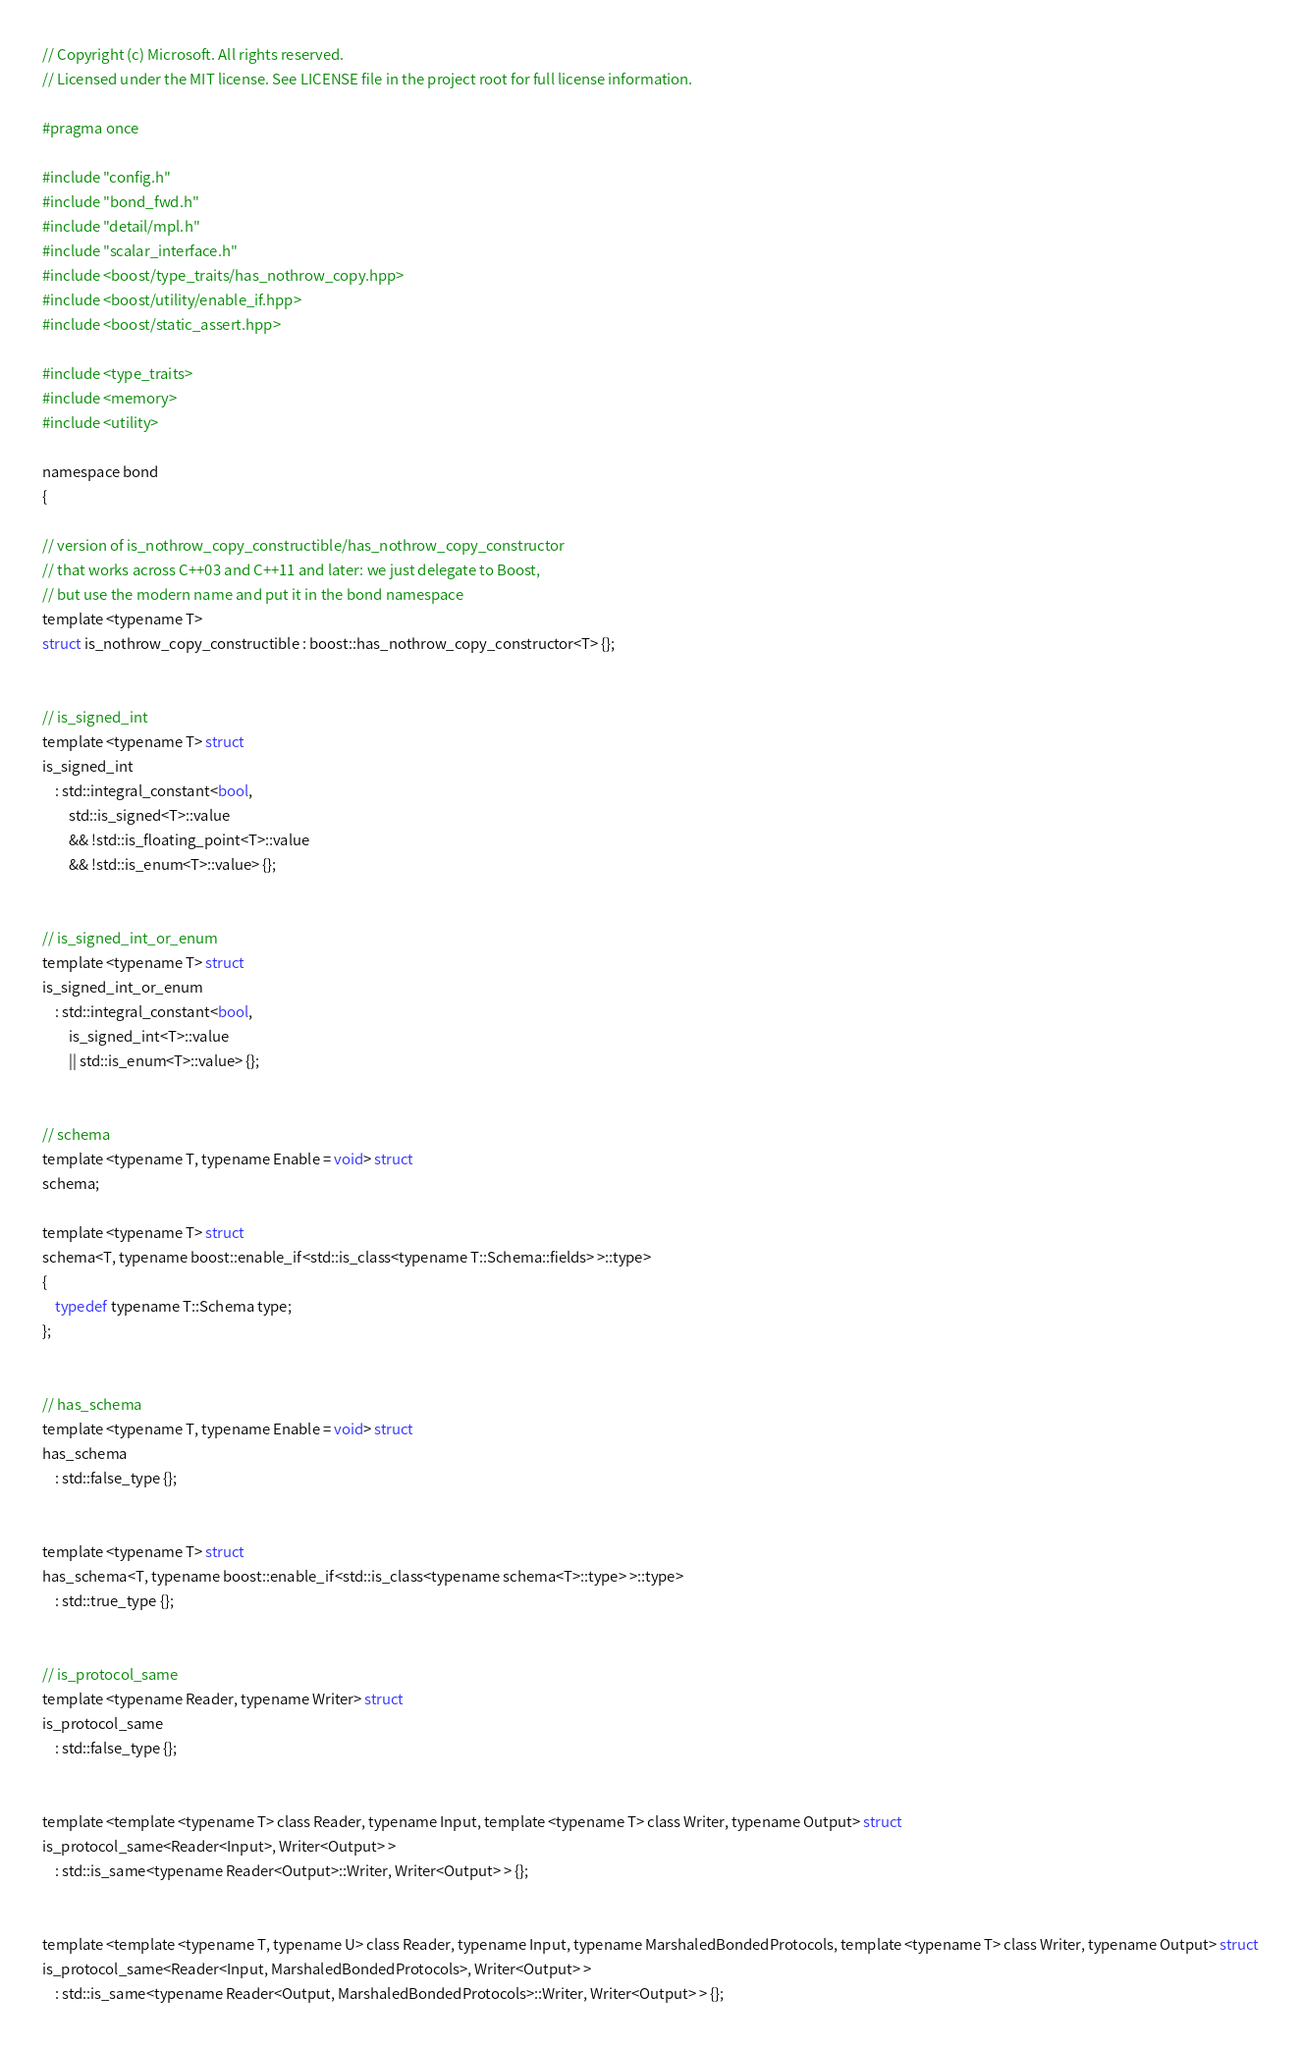Convert code to text. <code><loc_0><loc_0><loc_500><loc_500><_C_>// Copyright (c) Microsoft. All rights reserved.
// Licensed under the MIT license. See LICENSE file in the project root for full license information.

#pragma once

#include "config.h"
#include "bond_fwd.h"
#include "detail/mpl.h"
#include "scalar_interface.h"
#include <boost/type_traits/has_nothrow_copy.hpp>
#include <boost/utility/enable_if.hpp>
#include <boost/static_assert.hpp>

#include <type_traits>
#include <memory>
#include <utility>

namespace bond
{

// version of is_nothrow_copy_constructible/has_nothrow_copy_constructor
// that works across C++03 and C++11 and later: we just delegate to Boost,
// but use the modern name and put it in the bond namespace
template <typename T>
struct is_nothrow_copy_constructible : boost::has_nothrow_copy_constructor<T> {};


// is_signed_int
template <typename T> struct
is_signed_int
    : std::integral_constant<bool,
        std::is_signed<T>::value
        && !std::is_floating_point<T>::value
        && !std::is_enum<T>::value> {};


// is_signed_int_or_enum
template <typename T> struct
is_signed_int_or_enum
    : std::integral_constant<bool,
        is_signed_int<T>::value
        || std::is_enum<T>::value> {};


// schema
template <typename T, typename Enable = void> struct
schema;

template <typename T> struct
schema<T, typename boost::enable_if<std::is_class<typename T::Schema::fields> >::type>
{
    typedef typename T::Schema type;
};


// has_schema
template <typename T, typename Enable = void> struct
has_schema
    : std::false_type {};


template <typename T> struct
has_schema<T, typename boost::enable_if<std::is_class<typename schema<T>::type> >::type>
    : std::true_type {};


// is_protocol_same
template <typename Reader, typename Writer> struct
is_protocol_same
    : std::false_type {};


template <template <typename T> class Reader, typename Input, template <typename T> class Writer, typename Output> struct
is_protocol_same<Reader<Input>, Writer<Output> >
    : std::is_same<typename Reader<Output>::Writer, Writer<Output> > {};


template <template <typename T, typename U> class Reader, typename Input, typename MarshaledBondedProtocols, template <typename T> class Writer, typename Output> struct
is_protocol_same<Reader<Input, MarshaledBondedProtocols>, Writer<Output> >
    : std::is_same<typename Reader<Output, MarshaledBondedProtocols>::Writer, Writer<Output> > {};

</code> 